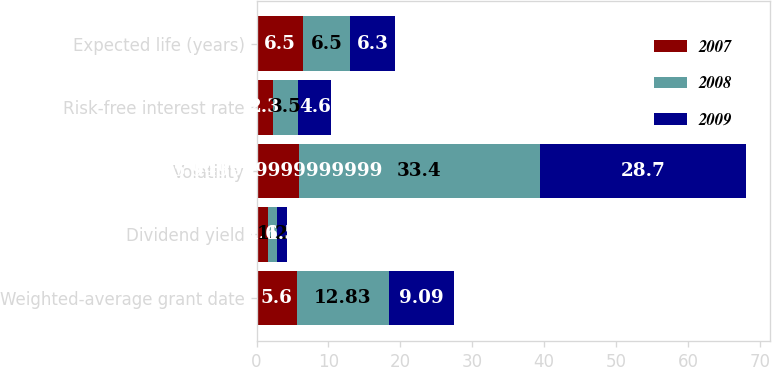<chart> <loc_0><loc_0><loc_500><loc_500><stacked_bar_chart><ecel><fcel>Weighted-average grant date<fcel>Dividend yield<fcel>Volatility<fcel>Risk-free interest rate<fcel>Expected life (years)<nl><fcel>2007<fcel>5.6<fcel>1.6<fcel>5.95<fcel>2.3<fcel>6.5<nl><fcel>2008<fcel>12.83<fcel>1.2<fcel>33.4<fcel>3.5<fcel>6.5<nl><fcel>2009<fcel>9.09<fcel>1.5<fcel>28.7<fcel>4.6<fcel>6.3<nl></chart> 